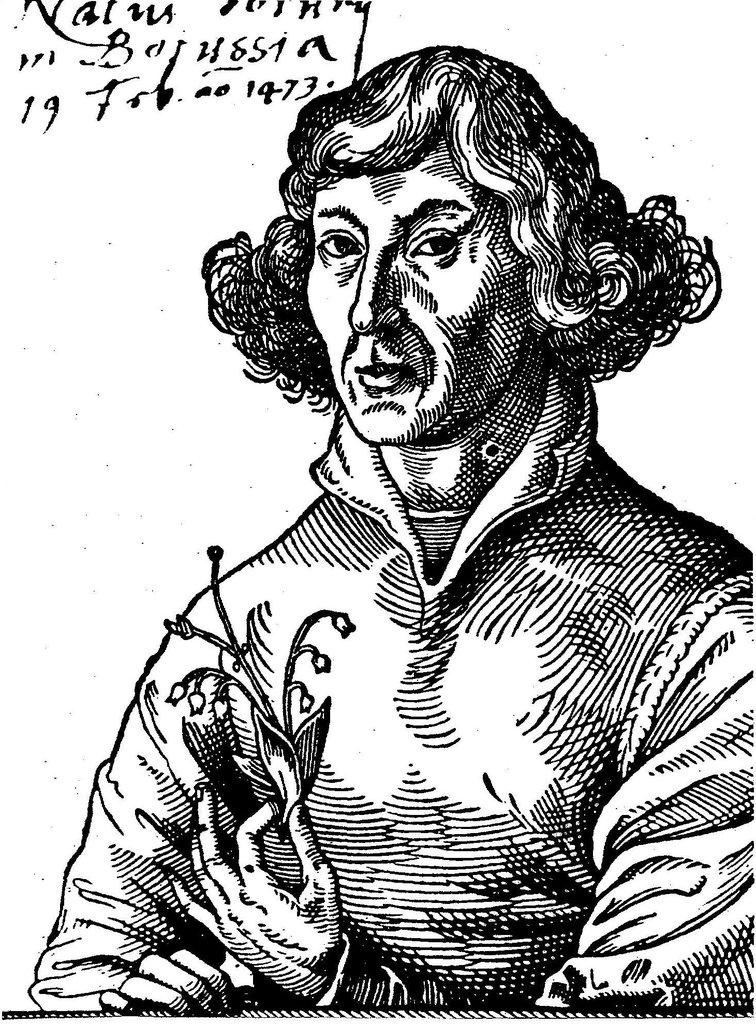What is the person in the image holding? The person is holding a flower in the image. What else can be seen in the image besides the person and the flower? There is text written in the image. What is the color of the background in the image? The background of the image is white. How much profit does the vessel in the image generate? There is no vessel present in the image, and therefore no profit can be associated with it. 